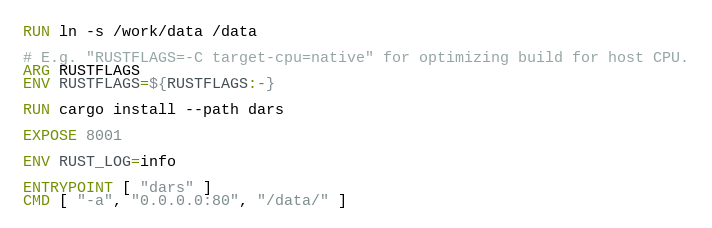<code> <loc_0><loc_0><loc_500><loc_500><_Dockerfile_>
RUN ln -s /work/data /data

# E.g. "RUSTFLAGS=-C target-cpu=native" for optimizing build for host CPU.
ARG RUSTFLAGS
ENV RUSTFLAGS=${RUSTFLAGS:-}

RUN cargo install --path dars

EXPOSE 8001

ENV RUST_LOG=info

ENTRYPOINT [ "dars" ]
CMD [ "-a", "0.0.0.0:80", "/data/" ]

</code> 